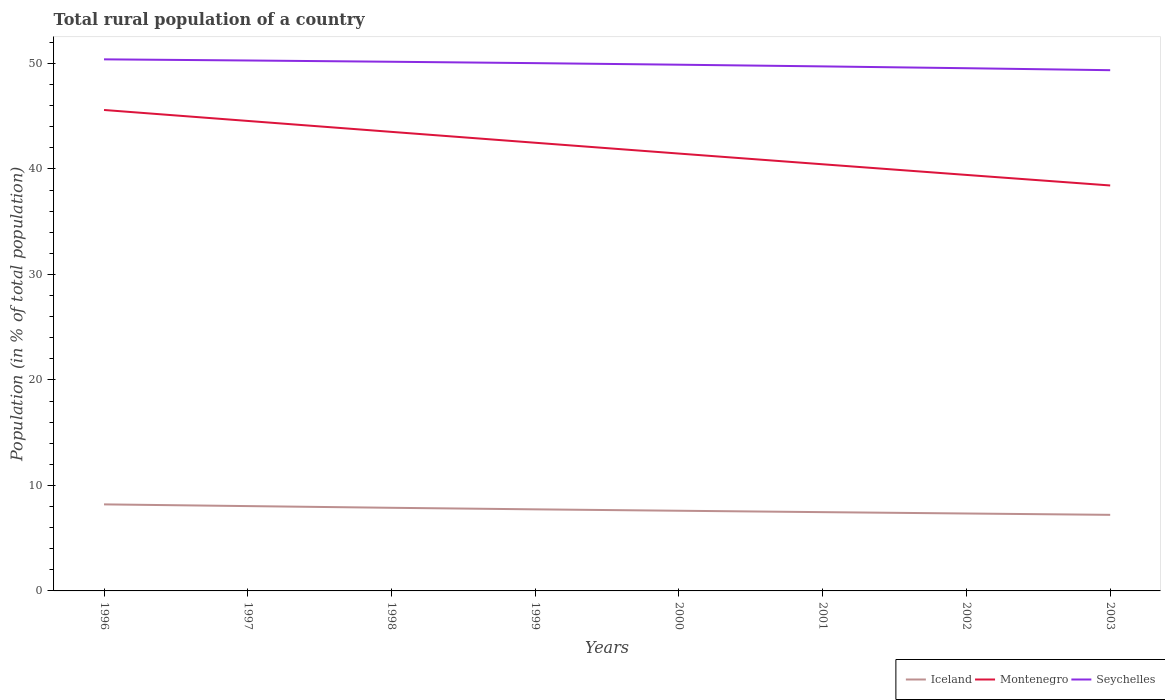Does the line corresponding to Iceland intersect with the line corresponding to Montenegro?
Your answer should be very brief. No. Across all years, what is the maximum rural population in Montenegro?
Your response must be concise. 38.43. What is the total rural population in Seychelles in the graph?
Provide a short and direct response. 0.23. What is the difference between the highest and the second highest rural population in Seychelles?
Your answer should be very brief. 1.03. What is the difference between the highest and the lowest rural population in Iceland?
Provide a short and direct response. 4. Is the rural population in Seychelles strictly greater than the rural population in Iceland over the years?
Your answer should be very brief. No. What is the difference between two consecutive major ticks on the Y-axis?
Provide a succinct answer. 10. Are the values on the major ticks of Y-axis written in scientific E-notation?
Give a very brief answer. No. Where does the legend appear in the graph?
Give a very brief answer. Bottom right. How many legend labels are there?
Keep it short and to the point. 3. What is the title of the graph?
Provide a succinct answer. Total rural population of a country. Does "Sierra Leone" appear as one of the legend labels in the graph?
Offer a terse response. No. What is the label or title of the X-axis?
Your response must be concise. Years. What is the label or title of the Y-axis?
Provide a short and direct response. Population (in % of total population). What is the Population (in % of total population) of Iceland in 1996?
Give a very brief answer. 8.2. What is the Population (in % of total population) of Montenegro in 1996?
Provide a short and direct response. 45.59. What is the Population (in % of total population) of Seychelles in 1996?
Your answer should be compact. 50.39. What is the Population (in % of total population) of Iceland in 1997?
Offer a terse response. 8.04. What is the Population (in % of total population) in Montenegro in 1997?
Give a very brief answer. 44.55. What is the Population (in % of total population) of Seychelles in 1997?
Offer a very short reply. 50.28. What is the Population (in % of total population) in Iceland in 1998?
Your answer should be very brief. 7.88. What is the Population (in % of total population) in Montenegro in 1998?
Offer a very short reply. 43.51. What is the Population (in % of total population) in Seychelles in 1998?
Your answer should be very brief. 50.16. What is the Population (in % of total population) in Iceland in 1999?
Your answer should be compact. 7.73. What is the Population (in % of total population) of Montenegro in 1999?
Offer a terse response. 42.48. What is the Population (in % of total population) in Seychelles in 1999?
Provide a short and direct response. 50.03. What is the Population (in % of total population) of Iceland in 2000?
Make the answer very short. 7.6. What is the Population (in % of total population) in Montenegro in 2000?
Make the answer very short. 41.46. What is the Population (in % of total population) of Seychelles in 2000?
Ensure brevity in your answer.  49.88. What is the Population (in % of total population) of Iceland in 2001?
Make the answer very short. 7.47. What is the Population (in % of total population) of Montenegro in 2001?
Make the answer very short. 40.44. What is the Population (in % of total population) in Seychelles in 2001?
Your answer should be compact. 49.72. What is the Population (in % of total population) of Iceland in 2002?
Provide a short and direct response. 7.34. What is the Population (in % of total population) in Montenegro in 2002?
Give a very brief answer. 39.43. What is the Population (in % of total population) of Seychelles in 2002?
Make the answer very short. 49.55. What is the Population (in % of total population) in Iceland in 2003?
Offer a very short reply. 7.21. What is the Population (in % of total population) of Montenegro in 2003?
Give a very brief answer. 38.43. What is the Population (in % of total population) of Seychelles in 2003?
Make the answer very short. 49.36. Across all years, what is the maximum Population (in % of total population) of Iceland?
Give a very brief answer. 8.2. Across all years, what is the maximum Population (in % of total population) in Montenegro?
Your answer should be very brief. 45.59. Across all years, what is the maximum Population (in % of total population) in Seychelles?
Your answer should be compact. 50.39. Across all years, what is the minimum Population (in % of total population) in Iceland?
Offer a very short reply. 7.21. Across all years, what is the minimum Population (in % of total population) of Montenegro?
Give a very brief answer. 38.43. Across all years, what is the minimum Population (in % of total population) of Seychelles?
Your answer should be very brief. 49.36. What is the total Population (in % of total population) in Iceland in the graph?
Give a very brief answer. 61.47. What is the total Population (in % of total population) in Montenegro in the graph?
Provide a short and direct response. 335.89. What is the total Population (in % of total population) of Seychelles in the graph?
Your response must be concise. 399.36. What is the difference between the Population (in % of total population) of Iceland in 1996 and that in 1997?
Your answer should be very brief. 0.16. What is the difference between the Population (in % of total population) in Montenegro in 1996 and that in 1997?
Your response must be concise. 1.04. What is the difference between the Population (in % of total population) in Seychelles in 1996 and that in 1997?
Keep it short and to the point. 0.11. What is the difference between the Population (in % of total population) in Iceland in 1996 and that in 1998?
Provide a succinct answer. 0.32. What is the difference between the Population (in % of total population) of Montenegro in 1996 and that in 1998?
Your response must be concise. 2.08. What is the difference between the Population (in % of total population) of Seychelles in 1996 and that in 1998?
Provide a short and direct response. 0.23. What is the difference between the Population (in % of total population) in Iceland in 1996 and that in 1999?
Provide a short and direct response. 0.47. What is the difference between the Population (in % of total population) in Montenegro in 1996 and that in 1999?
Keep it short and to the point. 3.11. What is the difference between the Population (in % of total population) in Seychelles in 1996 and that in 1999?
Provide a short and direct response. 0.36. What is the difference between the Population (in % of total population) of Iceland in 1996 and that in 2000?
Keep it short and to the point. 0.6. What is the difference between the Population (in % of total population) in Montenegro in 1996 and that in 2000?
Keep it short and to the point. 4.13. What is the difference between the Population (in % of total population) in Seychelles in 1996 and that in 2000?
Offer a very short reply. 0.51. What is the difference between the Population (in % of total population) in Iceland in 1996 and that in 2001?
Offer a terse response. 0.73. What is the difference between the Population (in % of total population) of Montenegro in 1996 and that in 2001?
Make the answer very short. 5.15. What is the difference between the Population (in % of total population) of Seychelles in 1996 and that in 2001?
Your answer should be very brief. 0.67. What is the difference between the Population (in % of total population) of Iceland in 1996 and that in 2002?
Make the answer very short. 0.86. What is the difference between the Population (in % of total population) in Montenegro in 1996 and that in 2002?
Give a very brief answer. 6.16. What is the difference between the Population (in % of total population) of Seychelles in 1996 and that in 2002?
Your answer should be very brief. 0.84. What is the difference between the Population (in % of total population) in Montenegro in 1996 and that in 2003?
Keep it short and to the point. 7.16. What is the difference between the Population (in % of total population) of Seychelles in 1996 and that in 2003?
Your answer should be very brief. 1.03. What is the difference between the Population (in % of total population) in Iceland in 1997 and that in 1998?
Your response must be concise. 0.16. What is the difference between the Population (in % of total population) of Seychelles in 1997 and that in 1998?
Provide a short and direct response. 0.12. What is the difference between the Population (in % of total population) in Iceland in 1997 and that in 1999?
Keep it short and to the point. 0.31. What is the difference between the Population (in % of total population) in Montenegro in 1997 and that in 1999?
Make the answer very short. 2.07. What is the difference between the Population (in % of total population) in Seychelles in 1997 and that in 1999?
Ensure brevity in your answer.  0.25. What is the difference between the Population (in % of total population) of Iceland in 1997 and that in 2000?
Your answer should be compact. 0.44. What is the difference between the Population (in % of total population) of Montenegro in 1997 and that in 2000?
Give a very brief answer. 3.09. What is the difference between the Population (in % of total population) in Iceland in 1997 and that in 2001?
Offer a terse response. 0.57. What is the difference between the Population (in % of total population) in Montenegro in 1997 and that in 2001?
Provide a succinct answer. 4.11. What is the difference between the Population (in % of total population) of Seychelles in 1997 and that in 2001?
Provide a succinct answer. 0.56. What is the difference between the Population (in % of total population) in Iceland in 1997 and that in 2002?
Offer a terse response. 0.7. What is the difference between the Population (in % of total population) of Montenegro in 1997 and that in 2002?
Your response must be concise. 5.12. What is the difference between the Population (in % of total population) in Seychelles in 1997 and that in 2002?
Your response must be concise. 0.73. What is the difference between the Population (in % of total population) in Iceland in 1997 and that in 2003?
Provide a short and direct response. 0.83. What is the difference between the Population (in % of total population) of Montenegro in 1997 and that in 2003?
Your response must be concise. 6.12. What is the difference between the Population (in % of total population) in Seychelles in 1997 and that in 2003?
Provide a succinct answer. 0.92. What is the difference between the Population (in % of total population) of Iceland in 1998 and that in 1999?
Ensure brevity in your answer.  0.15. What is the difference between the Population (in % of total population) in Montenegro in 1998 and that in 1999?
Keep it short and to the point. 1.03. What is the difference between the Population (in % of total population) of Seychelles in 1998 and that in 1999?
Offer a very short reply. 0.13. What is the difference between the Population (in % of total population) of Iceland in 1998 and that in 2000?
Your answer should be compact. 0.28. What is the difference between the Population (in % of total population) of Montenegro in 1998 and that in 2000?
Ensure brevity in your answer.  2.06. What is the difference between the Population (in % of total population) in Seychelles in 1998 and that in 2000?
Make the answer very short. 0.28. What is the difference between the Population (in % of total population) of Iceland in 1998 and that in 2001?
Keep it short and to the point. 0.41. What is the difference between the Population (in % of total population) of Montenegro in 1998 and that in 2001?
Offer a very short reply. 3.07. What is the difference between the Population (in % of total population) in Seychelles in 1998 and that in 2001?
Your response must be concise. 0.44. What is the difference between the Population (in % of total population) of Iceland in 1998 and that in 2002?
Your response must be concise. 0.54. What is the difference between the Population (in % of total population) in Montenegro in 1998 and that in 2002?
Provide a short and direct response. 4.08. What is the difference between the Population (in % of total population) in Seychelles in 1998 and that in 2002?
Make the answer very short. 0.61. What is the difference between the Population (in % of total population) in Iceland in 1998 and that in 2003?
Keep it short and to the point. 0.67. What is the difference between the Population (in % of total population) of Montenegro in 1998 and that in 2003?
Make the answer very short. 5.08. What is the difference between the Population (in % of total population) of Seychelles in 1998 and that in 2003?
Ensure brevity in your answer.  0.8. What is the difference between the Population (in % of total population) in Iceland in 1999 and that in 2000?
Offer a terse response. 0.13. What is the difference between the Population (in % of total population) in Seychelles in 1999 and that in 2000?
Provide a succinct answer. 0.15. What is the difference between the Population (in % of total population) in Iceland in 1999 and that in 2001?
Offer a terse response. 0.27. What is the difference between the Population (in % of total population) of Montenegro in 1999 and that in 2001?
Ensure brevity in your answer.  2.04. What is the difference between the Population (in % of total population) of Seychelles in 1999 and that in 2001?
Keep it short and to the point. 0.31. What is the difference between the Population (in % of total population) in Iceland in 1999 and that in 2002?
Your answer should be very brief. 0.4. What is the difference between the Population (in % of total population) of Montenegro in 1999 and that in 2002?
Offer a very short reply. 3.05. What is the difference between the Population (in % of total population) of Seychelles in 1999 and that in 2002?
Keep it short and to the point. 0.48. What is the difference between the Population (in % of total population) of Iceland in 1999 and that in 2003?
Provide a short and direct response. 0.52. What is the difference between the Population (in % of total population) in Montenegro in 1999 and that in 2003?
Ensure brevity in your answer.  4.05. What is the difference between the Population (in % of total population) of Seychelles in 1999 and that in 2003?
Ensure brevity in your answer.  0.67. What is the difference between the Population (in % of total population) in Iceland in 2000 and that in 2001?
Make the answer very short. 0.13. What is the difference between the Population (in % of total population) in Montenegro in 2000 and that in 2001?
Offer a terse response. 1.01. What is the difference between the Population (in % of total population) in Seychelles in 2000 and that in 2001?
Offer a terse response. 0.16. What is the difference between the Population (in % of total population) of Iceland in 2000 and that in 2002?
Provide a succinct answer. 0.26. What is the difference between the Population (in % of total population) of Montenegro in 2000 and that in 2002?
Your response must be concise. 2.02. What is the difference between the Population (in % of total population) of Seychelles in 2000 and that in 2002?
Keep it short and to the point. 0.33. What is the difference between the Population (in % of total population) of Iceland in 2000 and that in 2003?
Provide a short and direct response. 0.39. What is the difference between the Population (in % of total population) in Montenegro in 2000 and that in 2003?
Make the answer very short. 3.02. What is the difference between the Population (in % of total population) of Seychelles in 2000 and that in 2003?
Give a very brief answer. 0.52. What is the difference between the Population (in % of total population) in Iceland in 2001 and that in 2002?
Provide a short and direct response. 0.13. What is the difference between the Population (in % of total population) in Seychelles in 2001 and that in 2002?
Keep it short and to the point. 0.17. What is the difference between the Population (in % of total population) in Iceland in 2001 and that in 2003?
Your response must be concise. 0.26. What is the difference between the Population (in % of total population) in Montenegro in 2001 and that in 2003?
Your answer should be compact. 2.01. What is the difference between the Population (in % of total population) of Seychelles in 2001 and that in 2003?
Your response must be concise. 0.36. What is the difference between the Population (in % of total population) of Iceland in 2002 and that in 2003?
Your answer should be very brief. 0.13. What is the difference between the Population (in % of total population) of Montenegro in 2002 and that in 2003?
Keep it short and to the point. 1. What is the difference between the Population (in % of total population) of Seychelles in 2002 and that in 2003?
Your answer should be very brief. 0.19. What is the difference between the Population (in % of total population) in Iceland in 1996 and the Population (in % of total population) in Montenegro in 1997?
Keep it short and to the point. -36.35. What is the difference between the Population (in % of total population) of Iceland in 1996 and the Population (in % of total population) of Seychelles in 1997?
Keep it short and to the point. -42.08. What is the difference between the Population (in % of total population) of Montenegro in 1996 and the Population (in % of total population) of Seychelles in 1997?
Provide a succinct answer. -4.69. What is the difference between the Population (in % of total population) of Iceland in 1996 and the Population (in % of total population) of Montenegro in 1998?
Your response must be concise. -35.31. What is the difference between the Population (in % of total population) in Iceland in 1996 and the Population (in % of total population) in Seychelles in 1998?
Your answer should be very brief. -41.96. What is the difference between the Population (in % of total population) of Montenegro in 1996 and the Population (in % of total population) of Seychelles in 1998?
Provide a short and direct response. -4.57. What is the difference between the Population (in % of total population) in Iceland in 1996 and the Population (in % of total population) in Montenegro in 1999?
Ensure brevity in your answer.  -34.28. What is the difference between the Population (in % of total population) of Iceland in 1996 and the Population (in % of total population) of Seychelles in 1999?
Provide a short and direct response. -41.82. What is the difference between the Population (in % of total population) of Montenegro in 1996 and the Population (in % of total population) of Seychelles in 1999?
Your response must be concise. -4.44. What is the difference between the Population (in % of total population) in Iceland in 1996 and the Population (in % of total population) in Montenegro in 2000?
Offer a very short reply. -33.25. What is the difference between the Population (in % of total population) of Iceland in 1996 and the Population (in % of total population) of Seychelles in 2000?
Offer a terse response. -41.68. What is the difference between the Population (in % of total population) in Montenegro in 1996 and the Population (in % of total population) in Seychelles in 2000?
Keep it short and to the point. -4.29. What is the difference between the Population (in % of total population) of Iceland in 1996 and the Population (in % of total population) of Montenegro in 2001?
Give a very brief answer. -32.24. What is the difference between the Population (in % of total population) in Iceland in 1996 and the Population (in % of total population) in Seychelles in 2001?
Your answer should be compact. -41.52. What is the difference between the Population (in % of total population) of Montenegro in 1996 and the Population (in % of total population) of Seychelles in 2001?
Your response must be concise. -4.13. What is the difference between the Population (in % of total population) of Iceland in 1996 and the Population (in % of total population) of Montenegro in 2002?
Provide a succinct answer. -31.23. What is the difference between the Population (in % of total population) of Iceland in 1996 and the Population (in % of total population) of Seychelles in 2002?
Ensure brevity in your answer.  -41.34. What is the difference between the Population (in % of total population) in Montenegro in 1996 and the Population (in % of total population) in Seychelles in 2002?
Offer a very short reply. -3.96. What is the difference between the Population (in % of total population) in Iceland in 1996 and the Population (in % of total population) in Montenegro in 2003?
Your answer should be compact. -30.23. What is the difference between the Population (in % of total population) in Iceland in 1996 and the Population (in % of total population) in Seychelles in 2003?
Your answer should be compact. -41.16. What is the difference between the Population (in % of total population) of Montenegro in 1996 and the Population (in % of total population) of Seychelles in 2003?
Provide a succinct answer. -3.77. What is the difference between the Population (in % of total population) of Iceland in 1997 and the Population (in % of total population) of Montenegro in 1998?
Ensure brevity in your answer.  -35.47. What is the difference between the Population (in % of total population) of Iceland in 1997 and the Population (in % of total population) of Seychelles in 1998?
Your response must be concise. -42.12. What is the difference between the Population (in % of total population) in Montenegro in 1997 and the Population (in % of total population) in Seychelles in 1998?
Your response must be concise. -5.61. What is the difference between the Population (in % of total population) of Iceland in 1997 and the Population (in % of total population) of Montenegro in 1999?
Provide a succinct answer. -34.44. What is the difference between the Population (in % of total population) in Iceland in 1997 and the Population (in % of total population) in Seychelles in 1999?
Provide a short and direct response. -41.99. What is the difference between the Population (in % of total population) in Montenegro in 1997 and the Population (in % of total population) in Seychelles in 1999?
Make the answer very short. -5.48. What is the difference between the Population (in % of total population) in Iceland in 1997 and the Population (in % of total population) in Montenegro in 2000?
Provide a succinct answer. -33.42. What is the difference between the Population (in % of total population) of Iceland in 1997 and the Population (in % of total population) of Seychelles in 2000?
Your answer should be very brief. -41.84. What is the difference between the Population (in % of total population) of Montenegro in 1997 and the Population (in % of total population) of Seychelles in 2000?
Give a very brief answer. -5.33. What is the difference between the Population (in % of total population) in Iceland in 1997 and the Population (in % of total population) in Montenegro in 2001?
Make the answer very short. -32.4. What is the difference between the Population (in % of total population) in Iceland in 1997 and the Population (in % of total population) in Seychelles in 2001?
Offer a very short reply. -41.68. What is the difference between the Population (in % of total population) of Montenegro in 1997 and the Population (in % of total population) of Seychelles in 2001?
Provide a succinct answer. -5.17. What is the difference between the Population (in % of total population) in Iceland in 1997 and the Population (in % of total population) in Montenegro in 2002?
Make the answer very short. -31.39. What is the difference between the Population (in % of total population) of Iceland in 1997 and the Population (in % of total population) of Seychelles in 2002?
Give a very brief answer. -41.51. What is the difference between the Population (in % of total population) in Montenegro in 1997 and the Population (in % of total population) in Seychelles in 2002?
Keep it short and to the point. -5. What is the difference between the Population (in % of total population) of Iceland in 1997 and the Population (in % of total population) of Montenegro in 2003?
Keep it short and to the point. -30.39. What is the difference between the Population (in % of total population) in Iceland in 1997 and the Population (in % of total population) in Seychelles in 2003?
Ensure brevity in your answer.  -41.32. What is the difference between the Population (in % of total population) in Montenegro in 1997 and the Population (in % of total population) in Seychelles in 2003?
Offer a terse response. -4.81. What is the difference between the Population (in % of total population) of Iceland in 1998 and the Population (in % of total population) of Montenegro in 1999?
Keep it short and to the point. -34.6. What is the difference between the Population (in % of total population) in Iceland in 1998 and the Population (in % of total population) in Seychelles in 1999?
Offer a very short reply. -42.15. What is the difference between the Population (in % of total population) in Montenegro in 1998 and the Population (in % of total population) in Seychelles in 1999?
Make the answer very short. -6.51. What is the difference between the Population (in % of total population) of Iceland in 1998 and the Population (in % of total population) of Montenegro in 2000?
Keep it short and to the point. -33.58. What is the difference between the Population (in % of total population) in Iceland in 1998 and the Population (in % of total population) in Seychelles in 2000?
Make the answer very short. -42. What is the difference between the Population (in % of total population) of Montenegro in 1998 and the Population (in % of total population) of Seychelles in 2000?
Your answer should be very brief. -6.37. What is the difference between the Population (in % of total population) in Iceland in 1998 and the Population (in % of total population) in Montenegro in 2001?
Provide a short and direct response. -32.56. What is the difference between the Population (in % of total population) of Iceland in 1998 and the Population (in % of total population) of Seychelles in 2001?
Give a very brief answer. -41.84. What is the difference between the Population (in % of total population) of Montenegro in 1998 and the Population (in % of total population) of Seychelles in 2001?
Your answer should be very brief. -6.21. What is the difference between the Population (in % of total population) of Iceland in 1998 and the Population (in % of total population) of Montenegro in 2002?
Keep it short and to the point. -31.55. What is the difference between the Population (in % of total population) of Iceland in 1998 and the Population (in % of total population) of Seychelles in 2002?
Your response must be concise. -41.67. What is the difference between the Population (in % of total population) in Montenegro in 1998 and the Population (in % of total population) in Seychelles in 2002?
Keep it short and to the point. -6.03. What is the difference between the Population (in % of total population) of Iceland in 1998 and the Population (in % of total population) of Montenegro in 2003?
Ensure brevity in your answer.  -30.55. What is the difference between the Population (in % of total population) in Iceland in 1998 and the Population (in % of total population) in Seychelles in 2003?
Give a very brief answer. -41.48. What is the difference between the Population (in % of total population) of Montenegro in 1998 and the Population (in % of total population) of Seychelles in 2003?
Keep it short and to the point. -5.85. What is the difference between the Population (in % of total population) in Iceland in 1999 and the Population (in % of total population) in Montenegro in 2000?
Offer a terse response. -33.72. What is the difference between the Population (in % of total population) of Iceland in 1999 and the Population (in % of total population) of Seychelles in 2000?
Offer a very short reply. -42.15. What is the difference between the Population (in % of total population) of Montenegro in 1999 and the Population (in % of total population) of Seychelles in 2000?
Your answer should be compact. -7.4. What is the difference between the Population (in % of total population) of Iceland in 1999 and the Population (in % of total population) of Montenegro in 2001?
Your response must be concise. -32.71. What is the difference between the Population (in % of total population) in Iceland in 1999 and the Population (in % of total population) in Seychelles in 2001?
Ensure brevity in your answer.  -41.99. What is the difference between the Population (in % of total population) in Montenegro in 1999 and the Population (in % of total population) in Seychelles in 2001?
Give a very brief answer. -7.24. What is the difference between the Population (in % of total population) of Iceland in 1999 and the Population (in % of total population) of Montenegro in 2002?
Keep it short and to the point. -31.7. What is the difference between the Population (in % of total population) of Iceland in 1999 and the Population (in % of total population) of Seychelles in 2002?
Make the answer very short. -41.81. What is the difference between the Population (in % of total population) in Montenegro in 1999 and the Population (in % of total population) in Seychelles in 2002?
Offer a very short reply. -7.06. What is the difference between the Population (in % of total population) of Iceland in 1999 and the Population (in % of total population) of Montenegro in 2003?
Make the answer very short. -30.7. What is the difference between the Population (in % of total population) in Iceland in 1999 and the Population (in % of total population) in Seychelles in 2003?
Keep it short and to the point. -41.63. What is the difference between the Population (in % of total population) in Montenegro in 1999 and the Population (in % of total population) in Seychelles in 2003?
Your answer should be very brief. -6.88. What is the difference between the Population (in % of total population) in Iceland in 2000 and the Population (in % of total population) in Montenegro in 2001?
Provide a short and direct response. -32.84. What is the difference between the Population (in % of total population) in Iceland in 2000 and the Population (in % of total population) in Seychelles in 2001?
Ensure brevity in your answer.  -42.12. What is the difference between the Population (in % of total population) in Montenegro in 2000 and the Population (in % of total population) in Seychelles in 2001?
Offer a very short reply. -8.26. What is the difference between the Population (in % of total population) of Iceland in 2000 and the Population (in % of total population) of Montenegro in 2002?
Your answer should be compact. -31.83. What is the difference between the Population (in % of total population) of Iceland in 2000 and the Population (in % of total population) of Seychelles in 2002?
Offer a very short reply. -41.95. What is the difference between the Population (in % of total population) of Montenegro in 2000 and the Population (in % of total population) of Seychelles in 2002?
Your response must be concise. -8.09. What is the difference between the Population (in % of total population) of Iceland in 2000 and the Population (in % of total population) of Montenegro in 2003?
Provide a succinct answer. -30.83. What is the difference between the Population (in % of total population) in Iceland in 2000 and the Population (in % of total population) in Seychelles in 2003?
Make the answer very short. -41.76. What is the difference between the Population (in % of total population) in Montenegro in 2000 and the Population (in % of total population) in Seychelles in 2003?
Provide a succinct answer. -7.9. What is the difference between the Population (in % of total population) of Iceland in 2001 and the Population (in % of total population) of Montenegro in 2002?
Give a very brief answer. -31.96. What is the difference between the Population (in % of total population) of Iceland in 2001 and the Population (in % of total population) of Seychelles in 2002?
Offer a very short reply. -42.08. What is the difference between the Population (in % of total population) of Montenegro in 2001 and the Population (in % of total population) of Seychelles in 2002?
Give a very brief answer. -9.11. What is the difference between the Population (in % of total population) in Iceland in 2001 and the Population (in % of total population) in Montenegro in 2003?
Your answer should be very brief. -30.96. What is the difference between the Population (in % of total population) in Iceland in 2001 and the Population (in % of total population) in Seychelles in 2003?
Make the answer very short. -41.89. What is the difference between the Population (in % of total population) of Montenegro in 2001 and the Population (in % of total population) of Seychelles in 2003?
Offer a very short reply. -8.92. What is the difference between the Population (in % of total population) in Iceland in 2002 and the Population (in % of total population) in Montenegro in 2003?
Provide a succinct answer. -31.09. What is the difference between the Population (in % of total population) of Iceland in 2002 and the Population (in % of total population) of Seychelles in 2003?
Give a very brief answer. -42.02. What is the difference between the Population (in % of total population) in Montenegro in 2002 and the Population (in % of total population) in Seychelles in 2003?
Keep it short and to the point. -9.93. What is the average Population (in % of total population) in Iceland per year?
Your answer should be very brief. 7.68. What is the average Population (in % of total population) in Montenegro per year?
Give a very brief answer. 41.99. What is the average Population (in % of total population) of Seychelles per year?
Provide a succinct answer. 49.92. In the year 1996, what is the difference between the Population (in % of total population) of Iceland and Population (in % of total population) of Montenegro?
Give a very brief answer. -37.38. In the year 1996, what is the difference between the Population (in % of total population) of Iceland and Population (in % of total population) of Seychelles?
Provide a short and direct response. -42.18. In the year 1996, what is the difference between the Population (in % of total population) in Montenegro and Population (in % of total population) in Seychelles?
Make the answer very short. -4.8. In the year 1997, what is the difference between the Population (in % of total population) of Iceland and Population (in % of total population) of Montenegro?
Your response must be concise. -36.51. In the year 1997, what is the difference between the Population (in % of total population) in Iceland and Population (in % of total population) in Seychelles?
Offer a terse response. -42.24. In the year 1997, what is the difference between the Population (in % of total population) in Montenegro and Population (in % of total population) in Seychelles?
Give a very brief answer. -5.73. In the year 1998, what is the difference between the Population (in % of total population) in Iceland and Population (in % of total population) in Montenegro?
Make the answer very short. -35.63. In the year 1998, what is the difference between the Population (in % of total population) in Iceland and Population (in % of total population) in Seychelles?
Provide a succinct answer. -42.28. In the year 1998, what is the difference between the Population (in % of total population) in Montenegro and Population (in % of total population) in Seychelles?
Offer a terse response. -6.65. In the year 1999, what is the difference between the Population (in % of total population) of Iceland and Population (in % of total population) of Montenegro?
Provide a succinct answer. -34.75. In the year 1999, what is the difference between the Population (in % of total population) of Iceland and Population (in % of total population) of Seychelles?
Ensure brevity in your answer.  -42.29. In the year 1999, what is the difference between the Population (in % of total population) in Montenegro and Population (in % of total population) in Seychelles?
Make the answer very short. -7.54. In the year 2000, what is the difference between the Population (in % of total population) of Iceland and Population (in % of total population) of Montenegro?
Make the answer very short. -33.86. In the year 2000, what is the difference between the Population (in % of total population) in Iceland and Population (in % of total population) in Seychelles?
Ensure brevity in your answer.  -42.28. In the year 2000, what is the difference between the Population (in % of total population) of Montenegro and Population (in % of total population) of Seychelles?
Your answer should be very brief. -8.42. In the year 2001, what is the difference between the Population (in % of total population) of Iceland and Population (in % of total population) of Montenegro?
Offer a terse response. -32.97. In the year 2001, what is the difference between the Population (in % of total population) of Iceland and Population (in % of total population) of Seychelles?
Keep it short and to the point. -42.25. In the year 2001, what is the difference between the Population (in % of total population) of Montenegro and Population (in % of total population) of Seychelles?
Provide a succinct answer. -9.28. In the year 2002, what is the difference between the Population (in % of total population) in Iceland and Population (in % of total population) in Montenegro?
Provide a succinct answer. -32.09. In the year 2002, what is the difference between the Population (in % of total population) in Iceland and Population (in % of total population) in Seychelles?
Ensure brevity in your answer.  -42.21. In the year 2002, what is the difference between the Population (in % of total population) of Montenegro and Population (in % of total population) of Seychelles?
Provide a succinct answer. -10.11. In the year 2003, what is the difference between the Population (in % of total population) of Iceland and Population (in % of total population) of Montenegro?
Give a very brief answer. -31.22. In the year 2003, what is the difference between the Population (in % of total population) in Iceland and Population (in % of total population) in Seychelles?
Offer a very short reply. -42.15. In the year 2003, what is the difference between the Population (in % of total population) in Montenegro and Population (in % of total population) in Seychelles?
Offer a terse response. -10.93. What is the ratio of the Population (in % of total population) in Iceland in 1996 to that in 1997?
Provide a short and direct response. 1.02. What is the ratio of the Population (in % of total population) in Montenegro in 1996 to that in 1997?
Offer a very short reply. 1.02. What is the ratio of the Population (in % of total population) of Iceland in 1996 to that in 1998?
Keep it short and to the point. 1.04. What is the ratio of the Population (in % of total population) of Montenegro in 1996 to that in 1998?
Provide a short and direct response. 1.05. What is the ratio of the Population (in % of total population) in Iceland in 1996 to that in 1999?
Make the answer very short. 1.06. What is the ratio of the Population (in % of total population) in Montenegro in 1996 to that in 1999?
Provide a succinct answer. 1.07. What is the ratio of the Population (in % of total population) of Seychelles in 1996 to that in 1999?
Provide a short and direct response. 1.01. What is the ratio of the Population (in % of total population) of Iceland in 1996 to that in 2000?
Keep it short and to the point. 1.08. What is the ratio of the Population (in % of total population) of Montenegro in 1996 to that in 2000?
Give a very brief answer. 1.1. What is the ratio of the Population (in % of total population) in Seychelles in 1996 to that in 2000?
Offer a very short reply. 1.01. What is the ratio of the Population (in % of total population) in Iceland in 1996 to that in 2001?
Provide a succinct answer. 1.1. What is the ratio of the Population (in % of total population) in Montenegro in 1996 to that in 2001?
Your response must be concise. 1.13. What is the ratio of the Population (in % of total population) in Seychelles in 1996 to that in 2001?
Your answer should be very brief. 1.01. What is the ratio of the Population (in % of total population) in Iceland in 1996 to that in 2002?
Ensure brevity in your answer.  1.12. What is the ratio of the Population (in % of total population) of Montenegro in 1996 to that in 2002?
Offer a terse response. 1.16. What is the ratio of the Population (in % of total population) of Seychelles in 1996 to that in 2002?
Give a very brief answer. 1.02. What is the ratio of the Population (in % of total population) of Iceland in 1996 to that in 2003?
Make the answer very short. 1.14. What is the ratio of the Population (in % of total population) in Montenegro in 1996 to that in 2003?
Offer a terse response. 1.19. What is the ratio of the Population (in % of total population) in Seychelles in 1996 to that in 2003?
Make the answer very short. 1.02. What is the ratio of the Population (in % of total population) in Iceland in 1997 to that in 1998?
Your response must be concise. 1.02. What is the ratio of the Population (in % of total population) of Montenegro in 1997 to that in 1998?
Your answer should be very brief. 1.02. What is the ratio of the Population (in % of total population) of Seychelles in 1997 to that in 1998?
Provide a succinct answer. 1. What is the ratio of the Population (in % of total population) of Iceland in 1997 to that in 1999?
Your response must be concise. 1.04. What is the ratio of the Population (in % of total population) of Montenegro in 1997 to that in 1999?
Offer a very short reply. 1.05. What is the ratio of the Population (in % of total population) in Seychelles in 1997 to that in 1999?
Your response must be concise. 1.01. What is the ratio of the Population (in % of total population) of Iceland in 1997 to that in 2000?
Make the answer very short. 1.06. What is the ratio of the Population (in % of total population) in Montenegro in 1997 to that in 2000?
Ensure brevity in your answer.  1.07. What is the ratio of the Population (in % of total population) of Seychelles in 1997 to that in 2000?
Make the answer very short. 1.01. What is the ratio of the Population (in % of total population) in Iceland in 1997 to that in 2001?
Provide a succinct answer. 1.08. What is the ratio of the Population (in % of total population) of Montenegro in 1997 to that in 2001?
Give a very brief answer. 1.1. What is the ratio of the Population (in % of total population) in Seychelles in 1997 to that in 2001?
Your response must be concise. 1.01. What is the ratio of the Population (in % of total population) in Iceland in 1997 to that in 2002?
Your response must be concise. 1.1. What is the ratio of the Population (in % of total population) of Montenegro in 1997 to that in 2002?
Your answer should be compact. 1.13. What is the ratio of the Population (in % of total population) in Seychelles in 1997 to that in 2002?
Give a very brief answer. 1.01. What is the ratio of the Population (in % of total population) in Iceland in 1997 to that in 2003?
Your answer should be compact. 1.11. What is the ratio of the Population (in % of total population) of Montenegro in 1997 to that in 2003?
Provide a succinct answer. 1.16. What is the ratio of the Population (in % of total population) in Seychelles in 1997 to that in 2003?
Your response must be concise. 1.02. What is the ratio of the Population (in % of total population) of Iceland in 1998 to that in 1999?
Offer a terse response. 1.02. What is the ratio of the Population (in % of total population) of Montenegro in 1998 to that in 1999?
Offer a very short reply. 1.02. What is the ratio of the Population (in % of total population) of Seychelles in 1998 to that in 1999?
Keep it short and to the point. 1. What is the ratio of the Population (in % of total population) in Iceland in 1998 to that in 2000?
Provide a short and direct response. 1.04. What is the ratio of the Population (in % of total population) in Montenegro in 1998 to that in 2000?
Offer a terse response. 1.05. What is the ratio of the Population (in % of total population) of Seychelles in 1998 to that in 2000?
Your answer should be compact. 1.01. What is the ratio of the Population (in % of total population) in Iceland in 1998 to that in 2001?
Provide a succinct answer. 1.05. What is the ratio of the Population (in % of total population) of Montenegro in 1998 to that in 2001?
Your response must be concise. 1.08. What is the ratio of the Population (in % of total population) of Seychelles in 1998 to that in 2001?
Provide a short and direct response. 1.01. What is the ratio of the Population (in % of total population) of Iceland in 1998 to that in 2002?
Provide a succinct answer. 1.07. What is the ratio of the Population (in % of total population) in Montenegro in 1998 to that in 2002?
Keep it short and to the point. 1.1. What is the ratio of the Population (in % of total population) of Seychelles in 1998 to that in 2002?
Your answer should be compact. 1.01. What is the ratio of the Population (in % of total population) of Iceland in 1998 to that in 2003?
Provide a succinct answer. 1.09. What is the ratio of the Population (in % of total population) of Montenegro in 1998 to that in 2003?
Make the answer very short. 1.13. What is the ratio of the Population (in % of total population) in Seychelles in 1998 to that in 2003?
Your answer should be compact. 1.02. What is the ratio of the Population (in % of total population) in Iceland in 1999 to that in 2000?
Keep it short and to the point. 1.02. What is the ratio of the Population (in % of total population) in Montenegro in 1999 to that in 2000?
Provide a short and direct response. 1.02. What is the ratio of the Population (in % of total population) in Seychelles in 1999 to that in 2000?
Offer a terse response. 1. What is the ratio of the Population (in % of total population) of Iceland in 1999 to that in 2001?
Offer a terse response. 1.04. What is the ratio of the Population (in % of total population) in Montenegro in 1999 to that in 2001?
Offer a terse response. 1.05. What is the ratio of the Population (in % of total population) of Seychelles in 1999 to that in 2001?
Offer a terse response. 1.01. What is the ratio of the Population (in % of total population) of Iceland in 1999 to that in 2002?
Your answer should be compact. 1.05. What is the ratio of the Population (in % of total population) of Montenegro in 1999 to that in 2002?
Your answer should be compact. 1.08. What is the ratio of the Population (in % of total population) of Seychelles in 1999 to that in 2002?
Ensure brevity in your answer.  1.01. What is the ratio of the Population (in % of total population) of Iceland in 1999 to that in 2003?
Offer a terse response. 1.07. What is the ratio of the Population (in % of total population) in Montenegro in 1999 to that in 2003?
Keep it short and to the point. 1.11. What is the ratio of the Population (in % of total population) of Seychelles in 1999 to that in 2003?
Provide a short and direct response. 1.01. What is the ratio of the Population (in % of total population) in Iceland in 2000 to that in 2001?
Make the answer very short. 1.02. What is the ratio of the Population (in % of total population) in Montenegro in 2000 to that in 2001?
Your answer should be very brief. 1.03. What is the ratio of the Population (in % of total population) of Iceland in 2000 to that in 2002?
Your answer should be compact. 1.04. What is the ratio of the Population (in % of total population) in Montenegro in 2000 to that in 2002?
Your answer should be very brief. 1.05. What is the ratio of the Population (in % of total population) in Seychelles in 2000 to that in 2002?
Offer a terse response. 1.01. What is the ratio of the Population (in % of total population) of Iceland in 2000 to that in 2003?
Provide a succinct answer. 1.05. What is the ratio of the Population (in % of total population) of Montenegro in 2000 to that in 2003?
Your response must be concise. 1.08. What is the ratio of the Population (in % of total population) of Seychelles in 2000 to that in 2003?
Give a very brief answer. 1.01. What is the ratio of the Population (in % of total population) in Iceland in 2001 to that in 2002?
Keep it short and to the point. 1.02. What is the ratio of the Population (in % of total population) of Montenegro in 2001 to that in 2002?
Your answer should be very brief. 1.03. What is the ratio of the Population (in % of total population) of Seychelles in 2001 to that in 2002?
Make the answer very short. 1. What is the ratio of the Population (in % of total population) in Iceland in 2001 to that in 2003?
Provide a short and direct response. 1.04. What is the ratio of the Population (in % of total population) in Montenegro in 2001 to that in 2003?
Ensure brevity in your answer.  1.05. What is the ratio of the Population (in % of total population) of Seychelles in 2001 to that in 2003?
Give a very brief answer. 1.01. What is the ratio of the Population (in % of total population) in Iceland in 2002 to that in 2003?
Offer a terse response. 1.02. What is the difference between the highest and the second highest Population (in % of total population) in Iceland?
Your answer should be very brief. 0.16. What is the difference between the highest and the second highest Population (in % of total population) of Montenegro?
Provide a short and direct response. 1.04. What is the difference between the highest and the second highest Population (in % of total population) of Seychelles?
Your answer should be very brief. 0.11. What is the difference between the highest and the lowest Population (in % of total population) in Montenegro?
Your response must be concise. 7.16. What is the difference between the highest and the lowest Population (in % of total population) in Seychelles?
Offer a terse response. 1.03. 